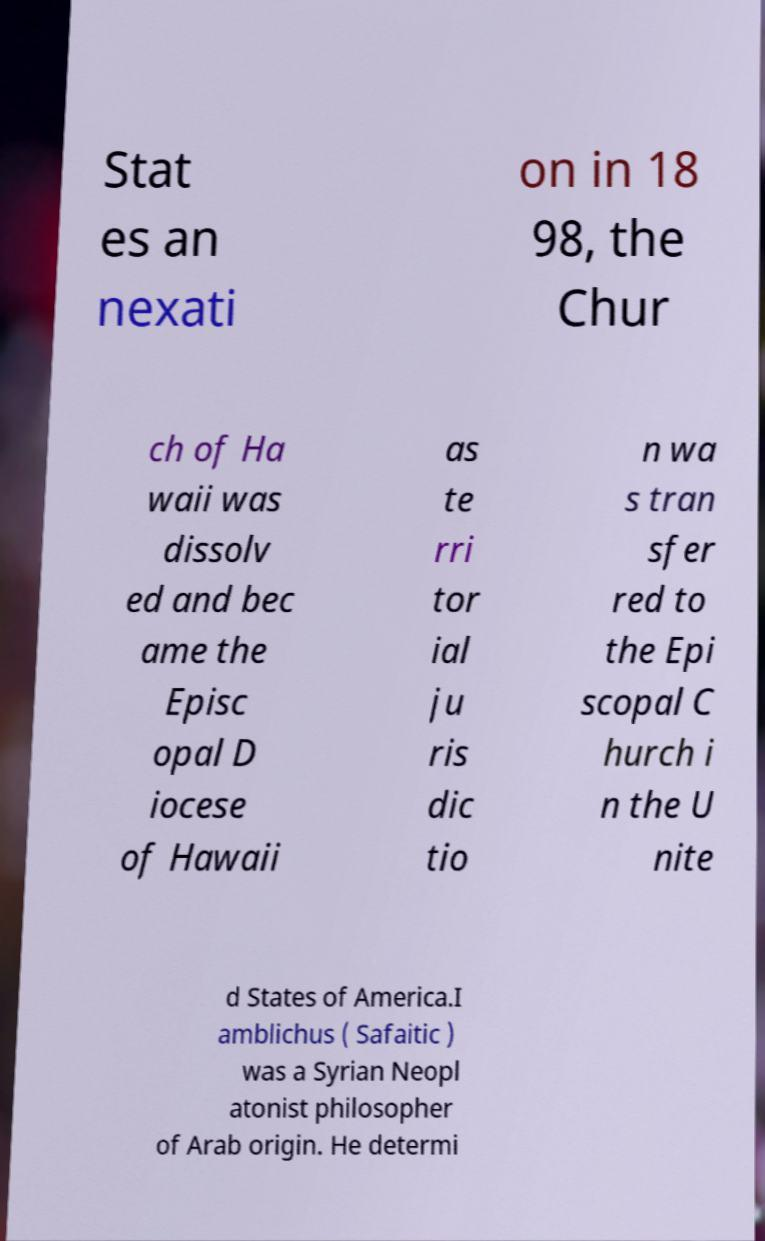Can you read and provide the text displayed in the image?This photo seems to have some interesting text. Can you extract and type it out for me? Stat es an nexati on in 18 98, the Chur ch of Ha waii was dissolv ed and bec ame the Episc opal D iocese of Hawaii as te rri tor ial ju ris dic tio n wa s tran sfer red to the Epi scopal C hurch i n the U nite d States of America.I amblichus ( Safaitic ) was a Syrian Neopl atonist philosopher of Arab origin. He determi 